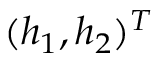<formula> <loc_0><loc_0><loc_500><loc_500>( h _ { 1 } , h _ { 2 } ) ^ { T }</formula> 